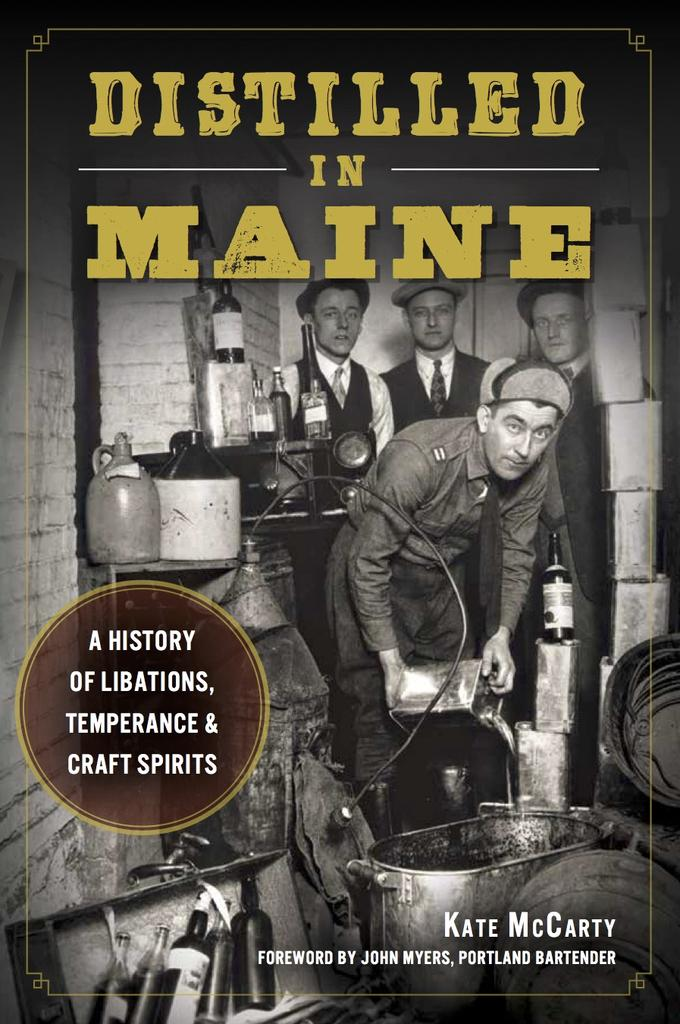What is featured on the poster in the image? The poster contains people, text, bottles, and other objects. Can you describe the people depicted on the poster? The provided facts do not give specific details about the people on the poster. What type of text is present on the poster? The poster contains text, but the specific content or message is not mentioned in the facts. What other objects are present on the poster besides bottles? The provided facts do not specify which other objects are present on the poster. Where is the zoo located in the image? There is no zoo present in the image; the main subject is a poster with various elements. What type of jeans are being worn by the people on the poster? The provided facts do not mention any clothing or jeans being worn by the people on the poster. 